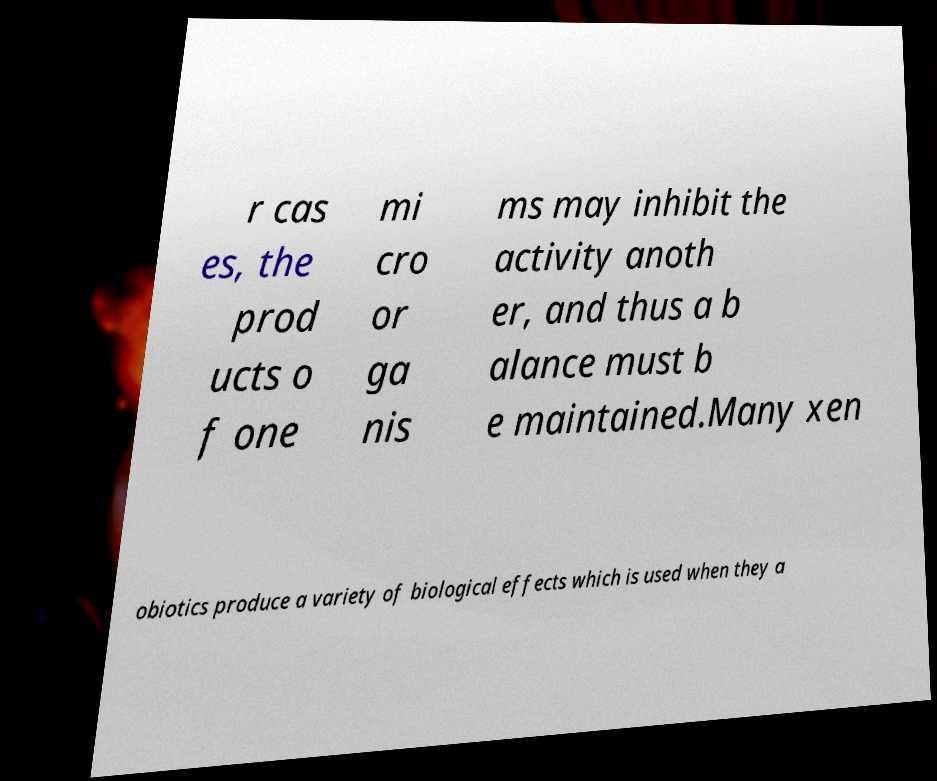Could you assist in decoding the text presented in this image and type it out clearly? r cas es, the prod ucts o f one mi cro or ga nis ms may inhibit the activity anoth er, and thus a b alance must b e maintained.Many xen obiotics produce a variety of biological effects which is used when they a 